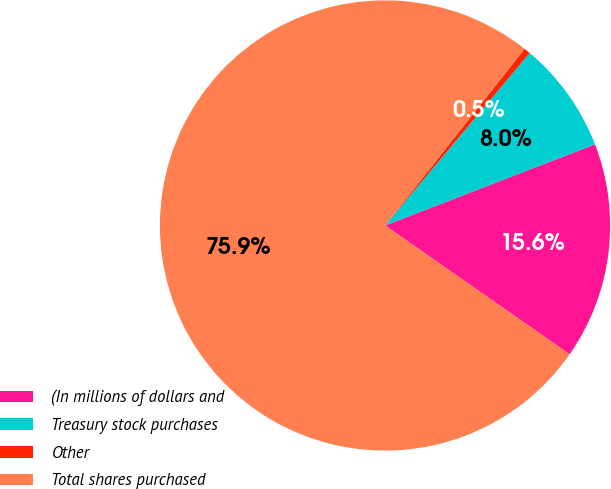<chart> <loc_0><loc_0><loc_500><loc_500><pie_chart><fcel>(In millions of dollars and<fcel>Treasury stock purchases<fcel>Other<fcel>Total shares purchased<nl><fcel>15.57%<fcel>8.02%<fcel>0.47%<fcel>75.94%<nl></chart> 